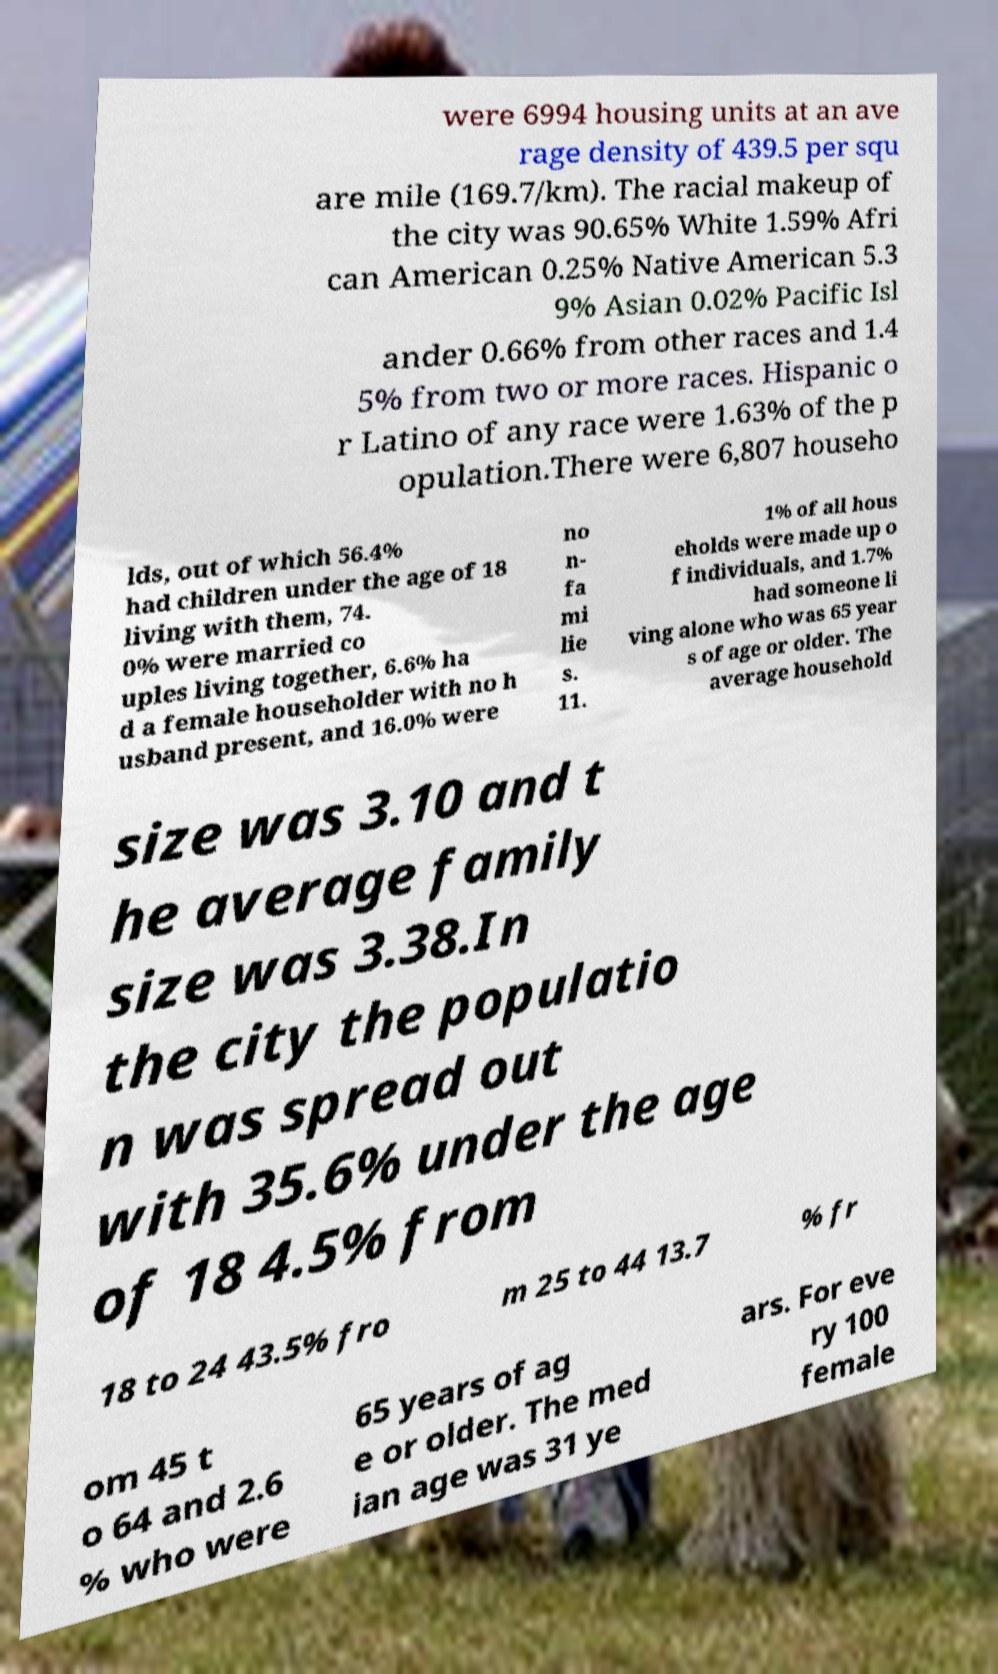Please read and relay the text visible in this image. What does it say? were 6994 housing units at an ave rage density of 439.5 per squ are mile (169.7/km). The racial makeup of the city was 90.65% White 1.59% Afri can American 0.25% Native American 5.3 9% Asian 0.02% Pacific Isl ander 0.66% from other races and 1.4 5% from two or more races. Hispanic o r Latino of any race were 1.63% of the p opulation.There were 6,807 househo lds, out of which 56.4% had children under the age of 18 living with them, 74. 0% were married co uples living together, 6.6% ha d a female householder with no h usband present, and 16.0% were no n- fa mi lie s. 11. 1% of all hous eholds were made up o f individuals, and 1.7% had someone li ving alone who was 65 year s of age or older. The average household size was 3.10 and t he average family size was 3.38.In the city the populatio n was spread out with 35.6% under the age of 18 4.5% from 18 to 24 43.5% fro m 25 to 44 13.7 % fr om 45 t o 64 and 2.6 % who were 65 years of ag e or older. The med ian age was 31 ye ars. For eve ry 100 female 